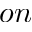Convert formula to latex. <formula><loc_0><loc_0><loc_500><loc_500>o n</formula> 